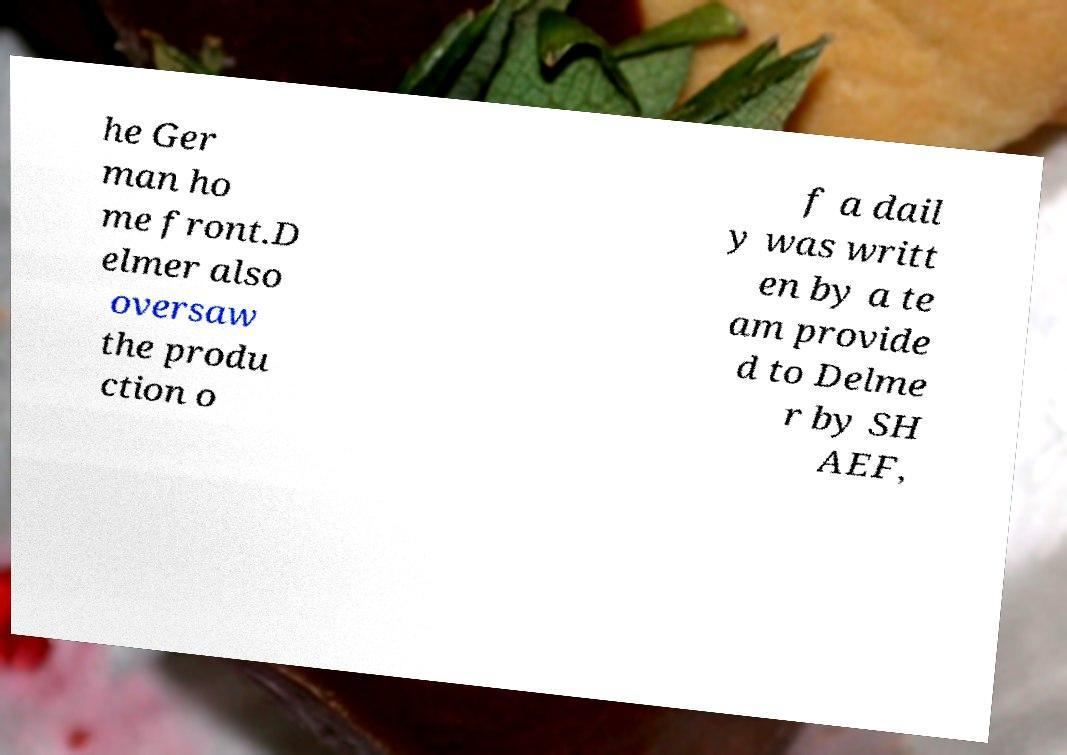I need the written content from this picture converted into text. Can you do that? he Ger man ho me front.D elmer also oversaw the produ ction o f a dail y was writt en by a te am provide d to Delme r by SH AEF, 